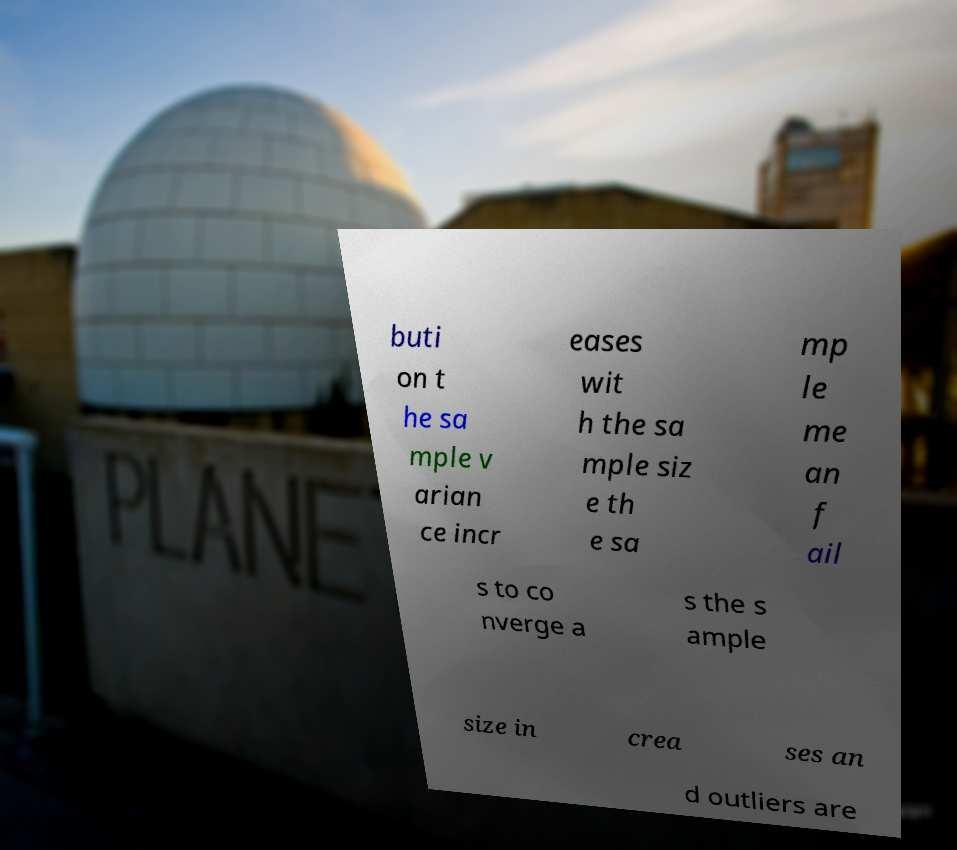Please identify and transcribe the text found in this image. buti on t he sa mple v arian ce incr eases wit h the sa mple siz e th e sa mp le me an f ail s to co nverge a s the s ample size in crea ses an d outliers are 